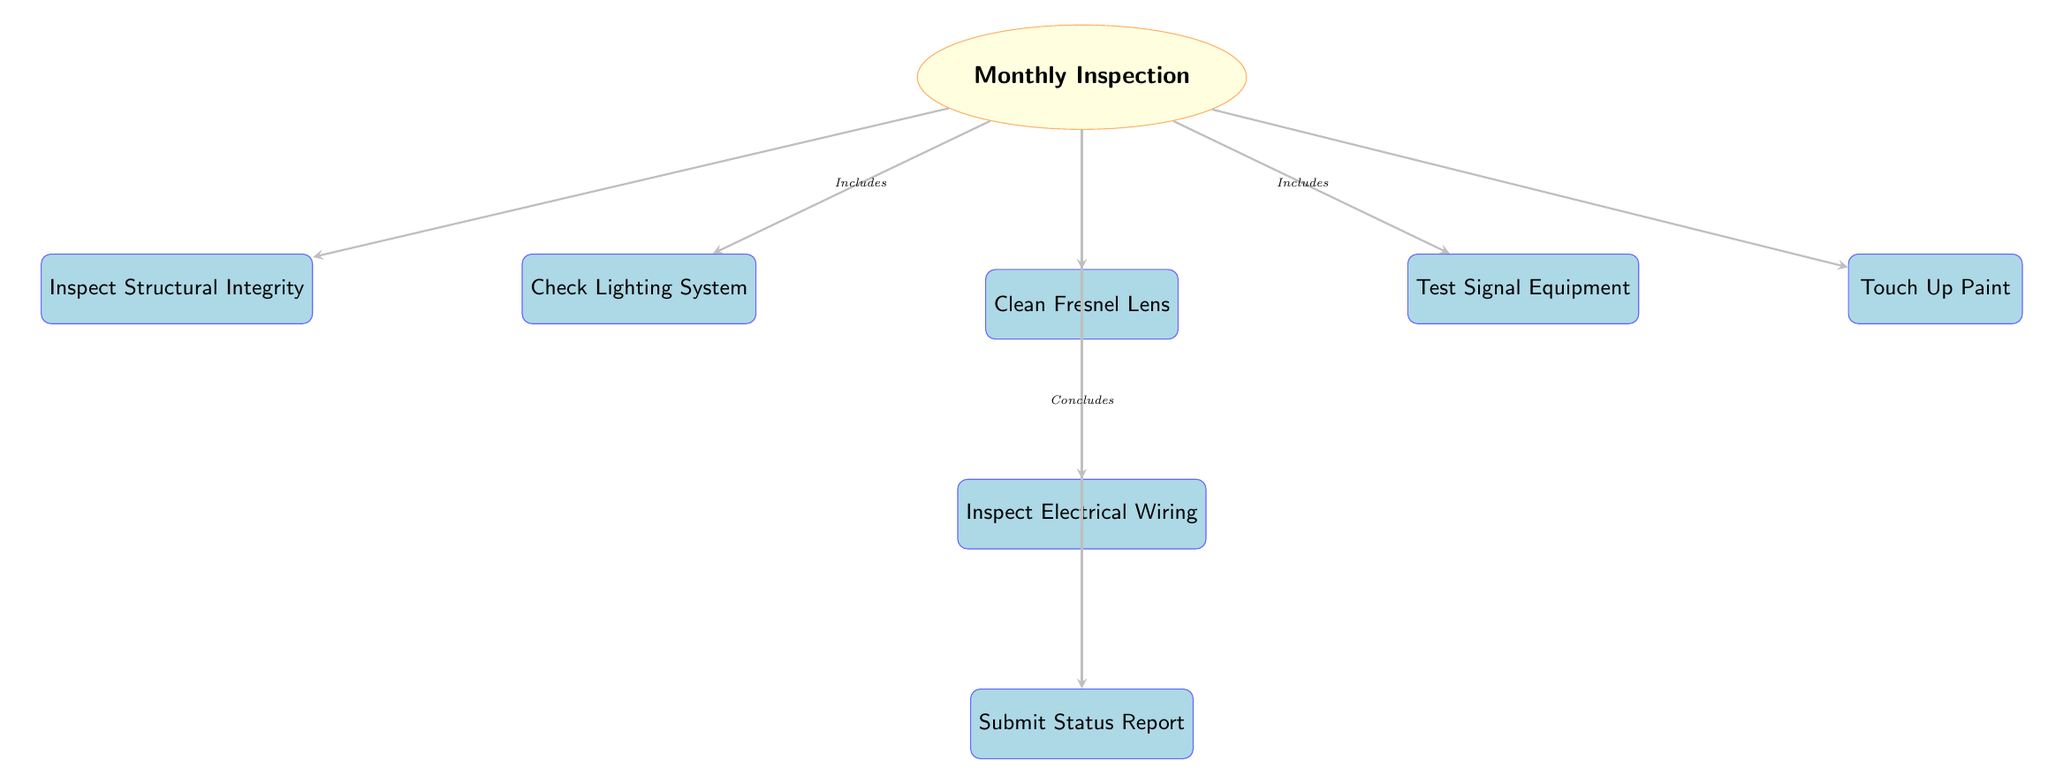What is the main action performed monthly? The diagram indicates that the main action is represented by the node labeled "Monthly Inspection." This is the central focus of the diagram, from which all other tasks branch out.
Answer: Monthly Inspection How many tasks are included under the Monthly Inspection? The diagram shows that there are six tasks branching off from the "Monthly Inspection" node: Check Lighting System, Clean Fresnel Lens, Test Signal Equipment, Inspect Structural Integrity, Touch Up Paint, and Inspect Electrical Wiring. Therefore, there are a total of six tasks.
Answer: 6 What task is located directly below the Clean Fresnel Lens task? Inspect Electrical Wiring is positioned directly below the Clean Fresnel Lens task in the diagram. This can be observed by following the vertical arrangement of the tasks starting from Clean Fresnel Lens downwards.
Answer: Inspect Electrical Wiring Which task is the last step in the maintenance schedule? The final task is represented by the node labeled "Submit Status Report." It is the last node in the sequence following all other tasks and is the culmination of the Monthly Inspection process.
Answer: Submit Status Report Which task is adjacent to the Check Lighting System task on the left side? On the left side of the Check Lighting System task, the task that is adjacent to it is Inspect Structural Integrity. This relationship can be confirmed by reviewing the spatial arrangement of the tasks in the diagram.
Answer: Inspect Structural Integrity How does the Monthly Inspection conclude? The diagram indicates that the Monthly Inspection process concludes with the node labeled "Submit Status Report," which is positioned at the bottom of the inspection flow. This is explicitly stated in the note connected to the arrow leading to that task.
Answer: Submit Status Report What color represents the task nodes in the diagram? The task nodes are represented in light blue color, as specified by the style attributes defined in the diagram structure. This is consistent throughout the task node appearances.
Answer: light blue What shape represents the main action in the diagram? The main action "Monthly Inspection" is represented by an ellipse, which can be identified by focusing on the distinct shape used for that node compared to the rectangular task nodes.
Answer: ellipse What arrow style is used throughout the diagram? The arrow style indicated in the code is described as "-stealth," which is a distinct and thick style used to visually connect the nodes throughout the diagram.
Answer: -stealth 